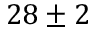<formula> <loc_0><loc_0><loc_500><loc_500>2 8 \pm 2</formula> 